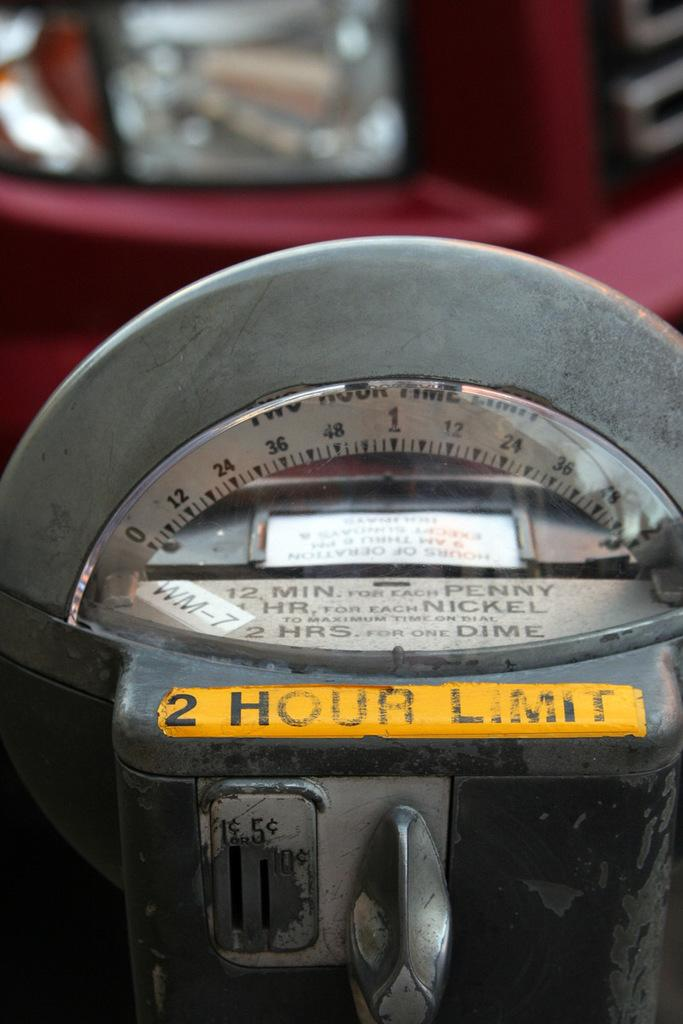Provide a one-sentence caption for the provided image. a meter with the number 2 on it. 